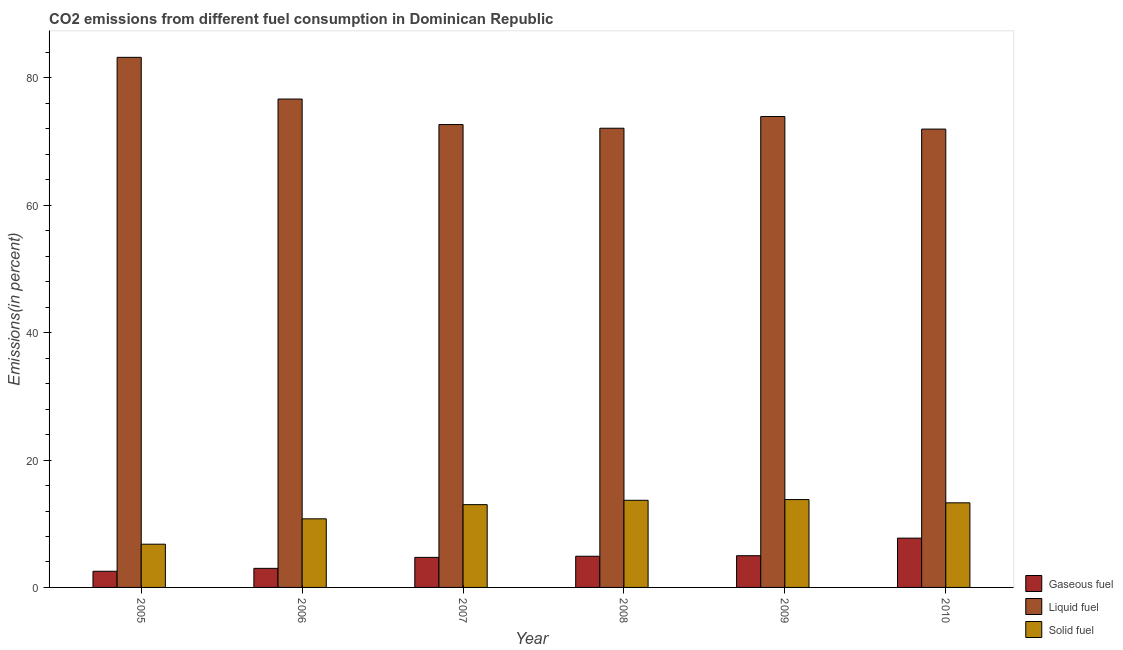Are the number of bars per tick equal to the number of legend labels?
Provide a short and direct response. Yes. Are the number of bars on each tick of the X-axis equal?
Keep it short and to the point. Yes. How many bars are there on the 6th tick from the right?
Give a very brief answer. 3. In how many cases, is the number of bars for a given year not equal to the number of legend labels?
Keep it short and to the point. 0. What is the percentage of gaseous fuel emission in 2007?
Keep it short and to the point. 4.72. Across all years, what is the maximum percentage of solid fuel emission?
Ensure brevity in your answer.  13.8. Across all years, what is the minimum percentage of gaseous fuel emission?
Keep it short and to the point. 2.54. In which year was the percentage of gaseous fuel emission maximum?
Keep it short and to the point. 2010. What is the total percentage of solid fuel emission in the graph?
Your answer should be very brief. 71.32. What is the difference between the percentage of gaseous fuel emission in 2005 and that in 2008?
Your answer should be compact. -2.36. What is the difference between the percentage of liquid fuel emission in 2006 and the percentage of gaseous fuel emission in 2008?
Provide a short and direct response. 4.58. What is the average percentage of gaseous fuel emission per year?
Offer a very short reply. 4.64. In the year 2005, what is the difference between the percentage of gaseous fuel emission and percentage of solid fuel emission?
Give a very brief answer. 0. What is the ratio of the percentage of solid fuel emission in 2007 to that in 2010?
Give a very brief answer. 0.98. Is the percentage of gaseous fuel emission in 2007 less than that in 2008?
Your answer should be very brief. Yes. What is the difference between the highest and the second highest percentage of solid fuel emission?
Offer a very short reply. 0.11. What is the difference between the highest and the lowest percentage of solid fuel emission?
Your answer should be very brief. 7.01. What does the 3rd bar from the left in 2009 represents?
Give a very brief answer. Solid fuel. What does the 3rd bar from the right in 2005 represents?
Offer a very short reply. Gaseous fuel. Are all the bars in the graph horizontal?
Your response must be concise. No. What is the difference between two consecutive major ticks on the Y-axis?
Your response must be concise. 20. Does the graph contain any zero values?
Offer a very short reply. No. Does the graph contain grids?
Your response must be concise. No. How are the legend labels stacked?
Give a very brief answer. Vertical. What is the title of the graph?
Your answer should be compact. CO2 emissions from different fuel consumption in Dominican Republic. What is the label or title of the X-axis?
Ensure brevity in your answer.  Year. What is the label or title of the Y-axis?
Your response must be concise. Emissions(in percent). What is the Emissions(in percent) in Gaseous fuel in 2005?
Make the answer very short. 2.54. What is the Emissions(in percent) in Liquid fuel in 2005?
Keep it short and to the point. 83.24. What is the Emissions(in percent) of Solid fuel in 2005?
Offer a terse response. 6.79. What is the Emissions(in percent) in Gaseous fuel in 2006?
Provide a succinct answer. 3. What is the Emissions(in percent) of Liquid fuel in 2006?
Offer a very short reply. 76.69. What is the Emissions(in percent) of Solid fuel in 2006?
Your answer should be compact. 10.77. What is the Emissions(in percent) in Gaseous fuel in 2007?
Your answer should be compact. 4.72. What is the Emissions(in percent) of Liquid fuel in 2007?
Make the answer very short. 72.68. What is the Emissions(in percent) of Solid fuel in 2007?
Your answer should be compact. 13. What is the Emissions(in percent) in Gaseous fuel in 2008?
Offer a terse response. 4.9. What is the Emissions(in percent) in Liquid fuel in 2008?
Your answer should be very brief. 72.11. What is the Emissions(in percent) in Solid fuel in 2008?
Offer a terse response. 13.68. What is the Emissions(in percent) of Gaseous fuel in 2009?
Give a very brief answer. 4.98. What is the Emissions(in percent) of Liquid fuel in 2009?
Keep it short and to the point. 73.94. What is the Emissions(in percent) of Solid fuel in 2009?
Your response must be concise. 13.8. What is the Emissions(in percent) in Gaseous fuel in 2010?
Make the answer very short. 7.74. What is the Emissions(in percent) in Liquid fuel in 2010?
Your response must be concise. 71.97. What is the Emissions(in percent) of Solid fuel in 2010?
Provide a short and direct response. 13.29. Across all years, what is the maximum Emissions(in percent) of Gaseous fuel?
Offer a very short reply. 7.74. Across all years, what is the maximum Emissions(in percent) of Liquid fuel?
Your response must be concise. 83.24. Across all years, what is the maximum Emissions(in percent) of Solid fuel?
Offer a terse response. 13.8. Across all years, what is the minimum Emissions(in percent) of Gaseous fuel?
Keep it short and to the point. 2.54. Across all years, what is the minimum Emissions(in percent) in Liquid fuel?
Make the answer very short. 71.97. Across all years, what is the minimum Emissions(in percent) of Solid fuel?
Ensure brevity in your answer.  6.79. What is the total Emissions(in percent) in Gaseous fuel in the graph?
Offer a very short reply. 27.87. What is the total Emissions(in percent) in Liquid fuel in the graph?
Ensure brevity in your answer.  450.63. What is the total Emissions(in percent) in Solid fuel in the graph?
Provide a succinct answer. 71.32. What is the difference between the Emissions(in percent) in Gaseous fuel in 2005 and that in 2006?
Give a very brief answer. -0.46. What is the difference between the Emissions(in percent) of Liquid fuel in 2005 and that in 2006?
Provide a short and direct response. 6.55. What is the difference between the Emissions(in percent) of Solid fuel in 2005 and that in 2006?
Your answer should be very brief. -3.98. What is the difference between the Emissions(in percent) of Gaseous fuel in 2005 and that in 2007?
Provide a short and direct response. -2.18. What is the difference between the Emissions(in percent) in Liquid fuel in 2005 and that in 2007?
Your answer should be very brief. 10.56. What is the difference between the Emissions(in percent) in Solid fuel in 2005 and that in 2007?
Ensure brevity in your answer.  -6.21. What is the difference between the Emissions(in percent) in Gaseous fuel in 2005 and that in 2008?
Provide a short and direct response. -2.36. What is the difference between the Emissions(in percent) in Liquid fuel in 2005 and that in 2008?
Give a very brief answer. 11.13. What is the difference between the Emissions(in percent) in Solid fuel in 2005 and that in 2008?
Give a very brief answer. -6.89. What is the difference between the Emissions(in percent) of Gaseous fuel in 2005 and that in 2009?
Your response must be concise. -2.44. What is the difference between the Emissions(in percent) of Liquid fuel in 2005 and that in 2009?
Give a very brief answer. 9.3. What is the difference between the Emissions(in percent) of Solid fuel in 2005 and that in 2009?
Provide a succinct answer. -7.01. What is the difference between the Emissions(in percent) in Gaseous fuel in 2005 and that in 2010?
Your answer should be very brief. -5.2. What is the difference between the Emissions(in percent) in Liquid fuel in 2005 and that in 2010?
Give a very brief answer. 11.27. What is the difference between the Emissions(in percent) in Solid fuel in 2005 and that in 2010?
Make the answer very short. -6.5. What is the difference between the Emissions(in percent) of Gaseous fuel in 2006 and that in 2007?
Give a very brief answer. -1.72. What is the difference between the Emissions(in percent) in Liquid fuel in 2006 and that in 2007?
Provide a succinct answer. 4.01. What is the difference between the Emissions(in percent) of Solid fuel in 2006 and that in 2007?
Offer a very short reply. -2.23. What is the difference between the Emissions(in percent) in Gaseous fuel in 2006 and that in 2008?
Your answer should be very brief. -1.9. What is the difference between the Emissions(in percent) of Liquid fuel in 2006 and that in 2008?
Your response must be concise. 4.58. What is the difference between the Emissions(in percent) in Solid fuel in 2006 and that in 2008?
Offer a terse response. -2.91. What is the difference between the Emissions(in percent) of Gaseous fuel in 2006 and that in 2009?
Keep it short and to the point. -1.98. What is the difference between the Emissions(in percent) in Liquid fuel in 2006 and that in 2009?
Offer a terse response. 2.75. What is the difference between the Emissions(in percent) in Solid fuel in 2006 and that in 2009?
Ensure brevity in your answer.  -3.02. What is the difference between the Emissions(in percent) in Gaseous fuel in 2006 and that in 2010?
Your response must be concise. -4.75. What is the difference between the Emissions(in percent) of Liquid fuel in 2006 and that in 2010?
Make the answer very short. 4.72. What is the difference between the Emissions(in percent) in Solid fuel in 2006 and that in 2010?
Your answer should be compact. -2.51. What is the difference between the Emissions(in percent) in Gaseous fuel in 2007 and that in 2008?
Your response must be concise. -0.18. What is the difference between the Emissions(in percent) in Liquid fuel in 2007 and that in 2008?
Provide a short and direct response. 0.57. What is the difference between the Emissions(in percent) of Solid fuel in 2007 and that in 2008?
Provide a succinct answer. -0.68. What is the difference between the Emissions(in percent) of Gaseous fuel in 2007 and that in 2009?
Provide a succinct answer. -0.26. What is the difference between the Emissions(in percent) in Liquid fuel in 2007 and that in 2009?
Your answer should be very brief. -1.26. What is the difference between the Emissions(in percent) of Solid fuel in 2007 and that in 2009?
Provide a short and direct response. -0.8. What is the difference between the Emissions(in percent) in Gaseous fuel in 2007 and that in 2010?
Provide a succinct answer. -3.02. What is the difference between the Emissions(in percent) in Liquid fuel in 2007 and that in 2010?
Provide a short and direct response. 0.71. What is the difference between the Emissions(in percent) in Solid fuel in 2007 and that in 2010?
Keep it short and to the point. -0.29. What is the difference between the Emissions(in percent) of Gaseous fuel in 2008 and that in 2009?
Your answer should be very brief. -0.08. What is the difference between the Emissions(in percent) of Liquid fuel in 2008 and that in 2009?
Offer a terse response. -1.84. What is the difference between the Emissions(in percent) in Solid fuel in 2008 and that in 2009?
Provide a short and direct response. -0.11. What is the difference between the Emissions(in percent) of Gaseous fuel in 2008 and that in 2010?
Make the answer very short. -2.84. What is the difference between the Emissions(in percent) of Liquid fuel in 2008 and that in 2010?
Provide a succinct answer. 0.14. What is the difference between the Emissions(in percent) of Solid fuel in 2008 and that in 2010?
Your response must be concise. 0.4. What is the difference between the Emissions(in percent) in Gaseous fuel in 2009 and that in 2010?
Provide a succinct answer. -2.76. What is the difference between the Emissions(in percent) of Liquid fuel in 2009 and that in 2010?
Provide a succinct answer. 1.97. What is the difference between the Emissions(in percent) of Solid fuel in 2009 and that in 2010?
Offer a terse response. 0.51. What is the difference between the Emissions(in percent) of Gaseous fuel in 2005 and the Emissions(in percent) of Liquid fuel in 2006?
Offer a very short reply. -74.15. What is the difference between the Emissions(in percent) in Gaseous fuel in 2005 and the Emissions(in percent) in Solid fuel in 2006?
Provide a short and direct response. -8.23. What is the difference between the Emissions(in percent) of Liquid fuel in 2005 and the Emissions(in percent) of Solid fuel in 2006?
Ensure brevity in your answer.  72.47. What is the difference between the Emissions(in percent) of Gaseous fuel in 2005 and the Emissions(in percent) of Liquid fuel in 2007?
Provide a short and direct response. -70.14. What is the difference between the Emissions(in percent) in Gaseous fuel in 2005 and the Emissions(in percent) in Solid fuel in 2007?
Your response must be concise. -10.46. What is the difference between the Emissions(in percent) of Liquid fuel in 2005 and the Emissions(in percent) of Solid fuel in 2007?
Give a very brief answer. 70.24. What is the difference between the Emissions(in percent) in Gaseous fuel in 2005 and the Emissions(in percent) in Liquid fuel in 2008?
Your response must be concise. -69.57. What is the difference between the Emissions(in percent) of Gaseous fuel in 2005 and the Emissions(in percent) of Solid fuel in 2008?
Ensure brevity in your answer.  -11.14. What is the difference between the Emissions(in percent) in Liquid fuel in 2005 and the Emissions(in percent) in Solid fuel in 2008?
Offer a very short reply. 69.56. What is the difference between the Emissions(in percent) in Gaseous fuel in 2005 and the Emissions(in percent) in Liquid fuel in 2009?
Ensure brevity in your answer.  -71.4. What is the difference between the Emissions(in percent) in Gaseous fuel in 2005 and the Emissions(in percent) in Solid fuel in 2009?
Offer a terse response. -11.26. What is the difference between the Emissions(in percent) in Liquid fuel in 2005 and the Emissions(in percent) in Solid fuel in 2009?
Your answer should be compact. 69.44. What is the difference between the Emissions(in percent) of Gaseous fuel in 2005 and the Emissions(in percent) of Liquid fuel in 2010?
Provide a succinct answer. -69.43. What is the difference between the Emissions(in percent) of Gaseous fuel in 2005 and the Emissions(in percent) of Solid fuel in 2010?
Provide a short and direct response. -10.75. What is the difference between the Emissions(in percent) in Liquid fuel in 2005 and the Emissions(in percent) in Solid fuel in 2010?
Ensure brevity in your answer.  69.95. What is the difference between the Emissions(in percent) in Gaseous fuel in 2006 and the Emissions(in percent) in Liquid fuel in 2007?
Provide a short and direct response. -69.69. What is the difference between the Emissions(in percent) of Gaseous fuel in 2006 and the Emissions(in percent) of Solid fuel in 2007?
Your answer should be compact. -10. What is the difference between the Emissions(in percent) of Liquid fuel in 2006 and the Emissions(in percent) of Solid fuel in 2007?
Your answer should be very brief. 63.69. What is the difference between the Emissions(in percent) in Gaseous fuel in 2006 and the Emissions(in percent) in Liquid fuel in 2008?
Provide a short and direct response. -69.11. What is the difference between the Emissions(in percent) of Gaseous fuel in 2006 and the Emissions(in percent) of Solid fuel in 2008?
Your response must be concise. -10.69. What is the difference between the Emissions(in percent) in Liquid fuel in 2006 and the Emissions(in percent) in Solid fuel in 2008?
Give a very brief answer. 63.01. What is the difference between the Emissions(in percent) of Gaseous fuel in 2006 and the Emissions(in percent) of Liquid fuel in 2009?
Your response must be concise. -70.95. What is the difference between the Emissions(in percent) of Gaseous fuel in 2006 and the Emissions(in percent) of Solid fuel in 2009?
Keep it short and to the point. -10.8. What is the difference between the Emissions(in percent) in Liquid fuel in 2006 and the Emissions(in percent) in Solid fuel in 2009?
Make the answer very short. 62.89. What is the difference between the Emissions(in percent) in Gaseous fuel in 2006 and the Emissions(in percent) in Liquid fuel in 2010?
Keep it short and to the point. -68.98. What is the difference between the Emissions(in percent) in Gaseous fuel in 2006 and the Emissions(in percent) in Solid fuel in 2010?
Keep it short and to the point. -10.29. What is the difference between the Emissions(in percent) of Liquid fuel in 2006 and the Emissions(in percent) of Solid fuel in 2010?
Provide a succinct answer. 63.4. What is the difference between the Emissions(in percent) in Gaseous fuel in 2007 and the Emissions(in percent) in Liquid fuel in 2008?
Your answer should be very brief. -67.39. What is the difference between the Emissions(in percent) in Gaseous fuel in 2007 and the Emissions(in percent) in Solid fuel in 2008?
Keep it short and to the point. -8.96. What is the difference between the Emissions(in percent) of Liquid fuel in 2007 and the Emissions(in percent) of Solid fuel in 2008?
Make the answer very short. 59. What is the difference between the Emissions(in percent) of Gaseous fuel in 2007 and the Emissions(in percent) of Liquid fuel in 2009?
Offer a very short reply. -69.23. What is the difference between the Emissions(in percent) in Gaseous fuel in 2007 and the Emissions(in percent) in Solid fuel in 2009?
Your answer should be compact. -9.08. What is the difference between the Emissions(in percent) of Liquid fuel in 2007 and the Emissions(in percent) of Solid fuel in 2009?
Keep it short and to the point. 58.88. What is the difference between the Emissions(in percent) in Gaseous fuel in 2007 and the Emissions(in percent) in Liquid fuel in 2010?
Give a very brief answer. -67.25. What is the difference between the Emissions(in percent) in Gaseous fuel in 2007 and the Emissions(in percent) in Solid fuel in 2010?
Provide a succinct answer. -8.57. What is the difference between the Emissions(in percent) of Liquid fuel in 2007 and the Emissions(in percent) of Solid fuel in 2010?
Make the answer very short. 59.4. What is the difference between the Emissions(in percent) in Gaseous fuel in 2008 and the Emissions(in percent) in Liquid fuel in 2009?
Your answer should be very brief. -69.05. What is the difference between the Emissions(in percent) in Gaseous fuel in 2008 and the Emissions(in percent) in Solid fuel in 2009?
Keep it short and to the point. -8.9. What is the difference between the Emissions(in percent) of Liquid fuel in 2008 and the Emissions(in percent) of Solid fuel in 2009?
Offer a very short reply. 58.31. What is the difference between the Emissions(in percent) in Gaseous fuel in 2008 and the Emissions(in percent) in Liquid fuel in 2010?
Your response must be concise. -67.07. What is the difference between the Emissions(in percent) in Gaseous fuel in 2008 and the Emissions(in percent) in Solid fuel in 2010?
Provide a short and direct response. -8.39. What is the difference between the Emissions(in percent) of Liquid fuel in 2008 and the Emissions(in percent) of Solid fuel in 2010?
Offer a very short reply. 58.82. What is the difference between the Emissions(in percent) of Gaseous fuel in 2009 and the Emissions(in percent) of Liquid fuel in 2010?
Offer a very short reply. -66.99. What is the difference between the Emissions(in percent) in Gaseous fuel in 2009 and the Emissions(in percent) in Solid fuel in 2010?
Ensure brevity in your answer.  -8.31. What is the difference between the Emissions(in percent) in Liquid fuel in 2009 and the Emissions(in percent) in Solid fuel in 2010?
Keep it short and to the point. 60.66. What is the average Emissions(in percent) of Gaseous fuel per year?
Give a very brief answer. 4.64. What is the average Emissions(in percent) in Liquid fuel per year?
Provide a succinct answer. 75.1. What is the average Emissions(in percent) in Solid fuel per year?
Provide a succinct answer. 11.89. In the year 2005, what is the difference between the Emissions(in percent) in Gaseous fuel and Emissions(in percent) in Liquid fuel?
Your answer should be very brief. -80.7. In the year 2005, what is the difference between the Emissions(in percent) of Gaseous fuel and Emissions(in percent) of Solid fuel?
Provide a short and direct response. -4.25. In the year 2005, what is the difference between the Emissions(in percent) of Liquid fuel and Emissions(in percent) of Solid fuel?
Provide a succinct answer. 76.45. In the year 2006, what is the difference between the Emissions(in percent) of Gaseous fuel and Emissions(in percent) of Liquid fuel?
Make the answer very short. -73.69. In the year 2006, what is the difference between the Emissions(in percent) of Gaseous fuel and Emissions(in percent) of Solid fuel?
Give a very brief answer. -7.78. In the year 2006, what is the difference between the Emissions(in percent) of Liquid fuel and Emissions(in percent) of Solid fuel?
Give a very brief answer. 65.92. In the year 2007, what is the difference between the Emissions(in percent) in Gaseous fuel and Emissions(in percent) in Liquid fuel?
Ensure brevity in your answer.  -67.96. In the year 2007, what is the difference between the Emissions(in percent) in Gaseous fuel and Emissions(in percent) in Solid fuel?
Keep it short and to the point. -8.28. In the year 2007, what is the difference between the Emissions(in percent) in Liquid fuel and Emissions(in percent) in Solid fuel?
Your answer should be very brief. 59.68. In the year 2008, what is the difference between the Emissions(in percent) in Gaseous fuel and Emissions(in percent) in Liquid fuel?
Provide a succinct answer. -67.21. In the year 2008, what is the difference between the Emissions(in percent) in Gaseous fuel and Emissions(in percent) in Solid fuel?
Make the answer very short. -8.78. In the year 2008, what is the difference between the Emissions(in percent) in Liquid fuel and Emissions(in percent) in Solid fuel?
Offer a terse response. 58.42. In the year 2009, what is the difference between the Emissions(in percent) in Gaseous fuel and Emissions(in percent) in Liquid fuel?
Your answer should be compact. -68.96. In the year 2009, what is the difference between the Emissions(in percent) of Gaseous fuel and Emissions(in percent) of Solid fuel?
Your response must be concise. -8.82. In the year 2009, what is the difference between the Emissions(in percent) in Liquid fuel and Emissions(in percent) in Solid fuel?
Your answer should be very brief. 60.15. In the year 2010, what is the difference between the Emissions(in percent) in Gaseous fuel and Emissions(in percent) in Liquid fuel?
Your response must be concise. -64.23. In the year 2010, what is the difference between the Emissions(in percent) of Gaseous fuel and Emissions(in percent) of Solid fuel?
Make the answer very short. -5.54. In the year 2010, what is the difference between the Emissions(in percent) in Liquid fuel and Emissions(in percent) in Solid fuel?
Your answer should be compact. 58.69. What is the ratio of the Emissions(in percent) of Gaseous fuel in 2005 to that in 2006?
Your answer should be very brief. 0.85. What is the ratio of the Emissions(in percent) in Liquid fuel in 2005 to that in 2006?
Keep it short and to the point. 1.09. What is the ratio of the Emissions(in percent) of Solid fuel in 2005 to that in 2006?
Keep it short and to the point. 0.63. What is the ratio of the Emissions(in percent) in Gaseous fuel in 2005 to that in 2007?
Your answer should be compact. 0.54. What is the ratio of the Emissions(in percent) in Liquid fuel in 2005 to that in 2007?
Make the answer very short. 1.15. What is the ratio of the Emissions(in percent) in Solid fuel in 2005 to that in 2007?
Your answer should be compact. 0.52. What is the ratio of the Emissions(in percent) in Gaseous fuel in 2005 to that in 2008?
Ensure brevity in your answer.  0.52. What is the ratio of the Emissions(in percent) of Liquid fuel in 2005 to that in 2008?
Your response must be concise. 1.15. What is the ratio of the Emissions(in percent) of Solid fuel in 2005 to that in 2008?
Provide a short and direct response. 0.5. What is the ratio of the Emissions(in percent) of Gaseous fuel in 2005 to that in 2009?
Keep it short and to the point. 0.51. What is the ratio of the Emissions(in percent) in Liquid fuel in 2005 to that in 2009?
Your answer should be compact. 1.13. What is the ratio of the Emissions(in percent) of Solid fuel in 2005 to that in 2009?
Offer a terse response. 0.49. What is the ratio of the Emissions(in percent) in Gaseous fuel in 2005 to that in 2010?
Make the answer very short. 0.33. What is the ratio of the Emissions(in percent) of Liquid fuel in 2005 to that in 2010?
Provide a succinct answer. 1.16. What is the ratio of the Emissions(in percent) of Solid fuel in 2005 to that in 2010?
Make the answer very short. 0.51. What is the ratio of the Emissions(in percent) in Gaseous fuel in 2006 to that in 2007?
Provide a succinct answer. 0.64. What is the ratio of the Emissions(in percent) in Liquid fuel in 2006 to that in 2007?
Ensure brevity in your answer.  1.06. What is the ratio of the Emissions(in percent) of Solid fuel in 2006 to that in 2007?
Your answer should be compact. 0.83. What is the ratio of the Emissions(in percent) of Gaseous fuel in 2006 to that in 2008?
Offer a terse response. 0.61. What is the ratio of the Emissions(in percent) of Liquid fuel in 2006 to that in 2008?
Make the answer very short. 1.06. What is the ratio of the Emissions(in percent) in Solid fuel in 2006 to that in 2008?
Ensure brevity in your answer.  0.79. What is the ratio of the Emissions(in percent) in Gaseous fuel in 2006 to that in 2009?
Keep it short and to the point. 0.6. What is the ratio of the Emissions(in percent) of Liquid fuel in 2006 to that in 2009?
Make the answer very short. 1.04. What is the ratio of the Emissions(in percent) of Solid fuel in 2006 to that in 2009?
Offer a very short reply. 0.78. What is the ratio of the Emissions(in percent) in Gaseous fuel in 2006 to that in 2010?
Provide a succinct answer. 0.39. What is the ratio of the Emissions(in percent) in Liquid fuel in 2006 to that in 2010?
Make the answer very short. 1.07. What is the ratio of the Emissions(in percent) in Solid fuel in 2006 to that in 2010?
Make the answer very short. 0.81. What is the ratio of the Emissions(in percent) of Gaseous fuel in 2007 to that in 2008?
Offer a very short reply. 0.96. What is the ratio of the Emissions(in percent) of Liquid fuel in 2007 to that in 2008?
Your response must be concise. 1.01. What is the ratio of the Emissions(in percent) of Solid fuel in 2007 to that in 2008?
Your answer should be compact. 0.95. What is the ratio of the Emissions(in percent) in Gaseous fuel in 2007 to that in 2009?
Your answer should be compact. 0.95. What is the ratio of the Emissions(in percent) in Liquid fuel in 2007 to that in 2009?
Provide a short and direct response. 0.98. What is the ratio of the Emissions(in percent) in Solid fuel in 2007 to that in 2009?
Your response must be concise. 0.94. What is the ratio of the Emissions(in percent) of Gaseous fuel in 2007 to that in 2010?
Provide a short and direct response. 0.61. What is the ratio of the Emissions(in percent) of Liquid fuel in 2007 to that in 2010?
Your answer should be very brief. 1.01. What is the ratio of the Emissions(in percent) of Solid fuel in 2007 to that in 2010?
Make the answer very short. 0.98. What is the ratio of the Emissions(in percent) in Gaseous fuel in 2008 to that in 2009?
Offer a very short reply. 0.98. What is the ratio of the Emissions(in percent) of Liquid fuel in 2008 to that in 2009?
Provide a succinct answer. 0.98. What is the ratio of the Emissions(in percent) in Solid fuel in 2008 to that in 2009?
Provide a short and direct response. 0.99. What is the ratio of the Emissions(in percent) of Gaseous fuel in 2008 to that in 2010?
Ensure brevity in your answer.  0.63. What is the ratio of the Emissions(in percent) in Solid fuel in 2008 to that in 2010?
Give a very brief answer. 1.03. What is the ratio of the Emissions(in percent) in Gaseous fuel in 2009 to that in 2010?
Offer a terse response. 0.64. What is the ratio of the Emissions(in percent) in Liquid fuel in 2009 to that in 2010?
Provide a succinct answer. 1.03. What is the difference between the highest and the second highest Emissions(in percent) in Gaseous fuel?
Your response must be concise. 2.76. What is the difference between the highest and the second highest Emissions(in percent) in Liquid fuel?
Give a very brief answer. 6.55. What is the difference between the highest and the second highest Emissions(in percent) of Solid fuel?
Ensure brevity in your answer.  0.11. What is the difference between the highest and the lowest Emissions(in percent) of Gaseous fuel?
Your response must be concise. 5.2. What is the difference between the highest and the lowest Emissions(in percent) in Liquid fuel?
Provide a succinct answer. 11.27. What is the difference between the highest and the lowest Emissions(in percent) of Solid fuel?
Offer a terse response. 7.01. 